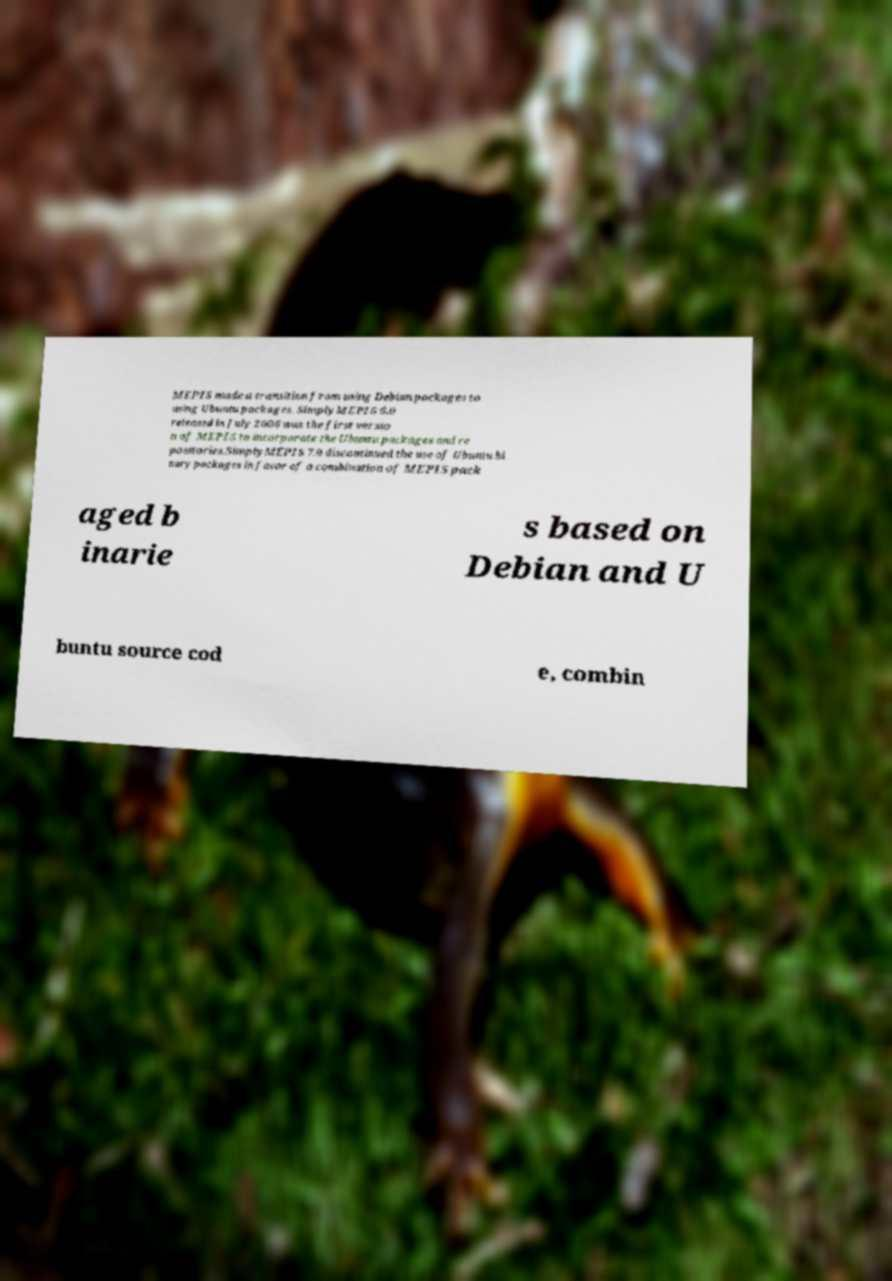What messages or text are displayed in this image? I need them in a readable, typed format. MEPIS made a transition from using Debian packages to using Ubuntu packages. SimplyMEPIS 6.0 released in July 2006 was the first versio n of MEPIS to incorporate the Ubuntu packages and re positories.SimplyMEPIS 7.0 discontinued the use of Ubuntu bi nary packages in favor of a combination of MEPIS pack aged b inarie s based on Debian and U buntu source cod e, combin 